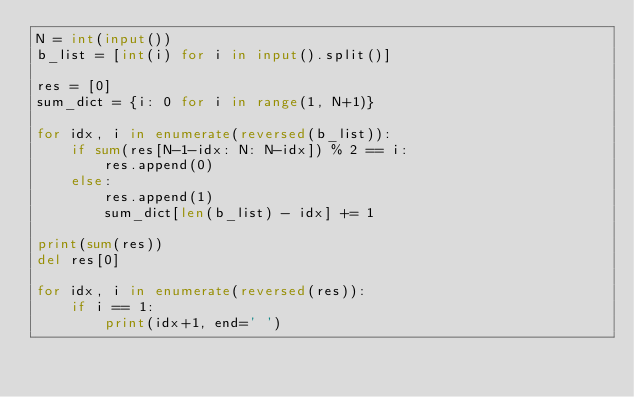<code> <loc_0><loc_0><loc_500><loc_500><_Python_>N = int(input())
b_list = [int(i) for i in input().split()]

res = [0]
sum_dict = {i: 0 for i in range(1, N+1)}

for idx, i in enumerate(reversed(b_list)):
    if sum(res[N-1-idx: N: N-idx]) % 2 == i:
        res.append(0)
    else:
        res.append(1)
        sum_dict[len(b_list) - idx] += 1

print(sum(res))
del res[0]

for idx, i in enumerate(reversed(res)):
    if i == 1:
        print(idx+1, end=' ')
</code> 